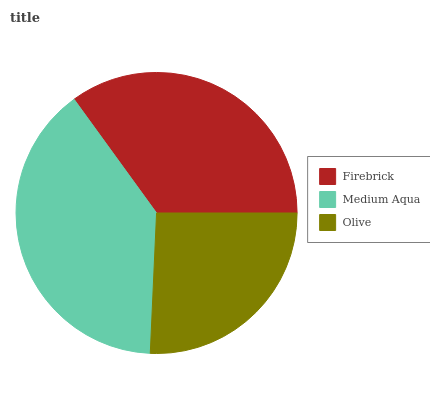Is Olive the minimum?
Answer yes or no. Yes. Is Medium Aqua the maximum?
Answer yes or no. Yes. Is Medium Aqua the minimum?
Answer yes or no. No. Is Olive the maximum?
Answer yes or no. No. Is Medium Aqua greater than Olive?
Answer yes or no. Yes. Is Olive less than Medium Aqua?
Answer yes or no. Yes. Is Olive greater than Medium Aqua?
Answer yes or no. No. Is Medium Aqua less than Olive?
Answer yes or no. No. Is Firebrick the high median?
Answer yes or no. Yes. Is Firebrick the low median?
Answer yes or no. Yes. Is Medium Aqua the high median?
Answer yes or no. No. Is Olive the low median?
Answer yes or no. No. 